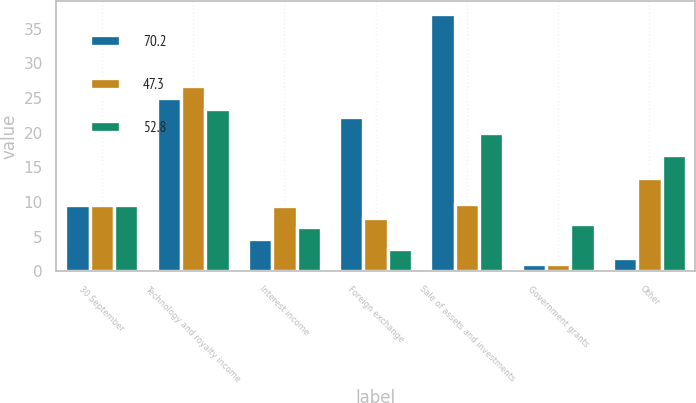Convert chart to OTSL. <chart><loc_0><loc_0><loc_500><loc_500><stacked_bar_chart><ecel><fcel>30 September<fcel>Technology and royalty income<fcel>Interest income<fcel>Foreign exchange<fcel>Sale of assets and investments<fcel>Government grants<fcel>Other<nl><fcel>70.2<fcel>9.55<fcel>25<fcel>4.6<fcel>22.3<fcel>37.1<fcel>1<fcel>1.9<nl><fcel>47.3<fcel>9.55<fcel>26.8<fcel>9.4<fcel>7.7<fcel>9.7<fcel>1.1<fcel>13.5<nl><fcel>52.8<fcel>9.55<fcel>23.4<fcel>6.4<fcel>3.2<fcel>20<fcel>6.8<fcel>16.8<nl></chart> 